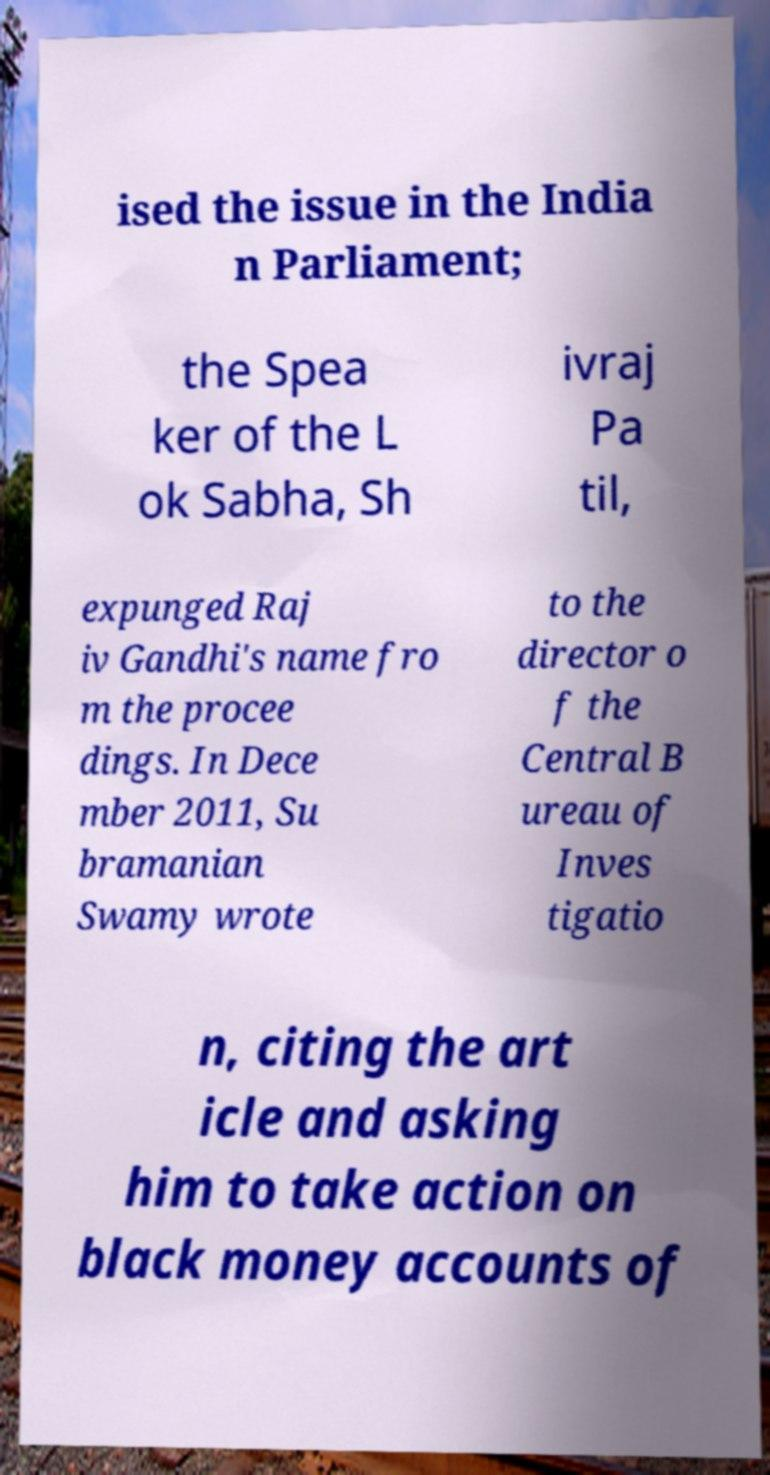Could you assist in decoding the text presented in this image and type it out clearly? ised the issue in the India n Parliament; the Spea ker of the L ok Sabha, Sh ivraj Pa til, expunged Raj iv Gandhi's name fro m the procee dings. In Dece mber 2011, Su bramanian Swamy wrote to the director o f the Central B ureau of Inves tigatio n, citing the art icle and asking him to take action on black money accounts of 